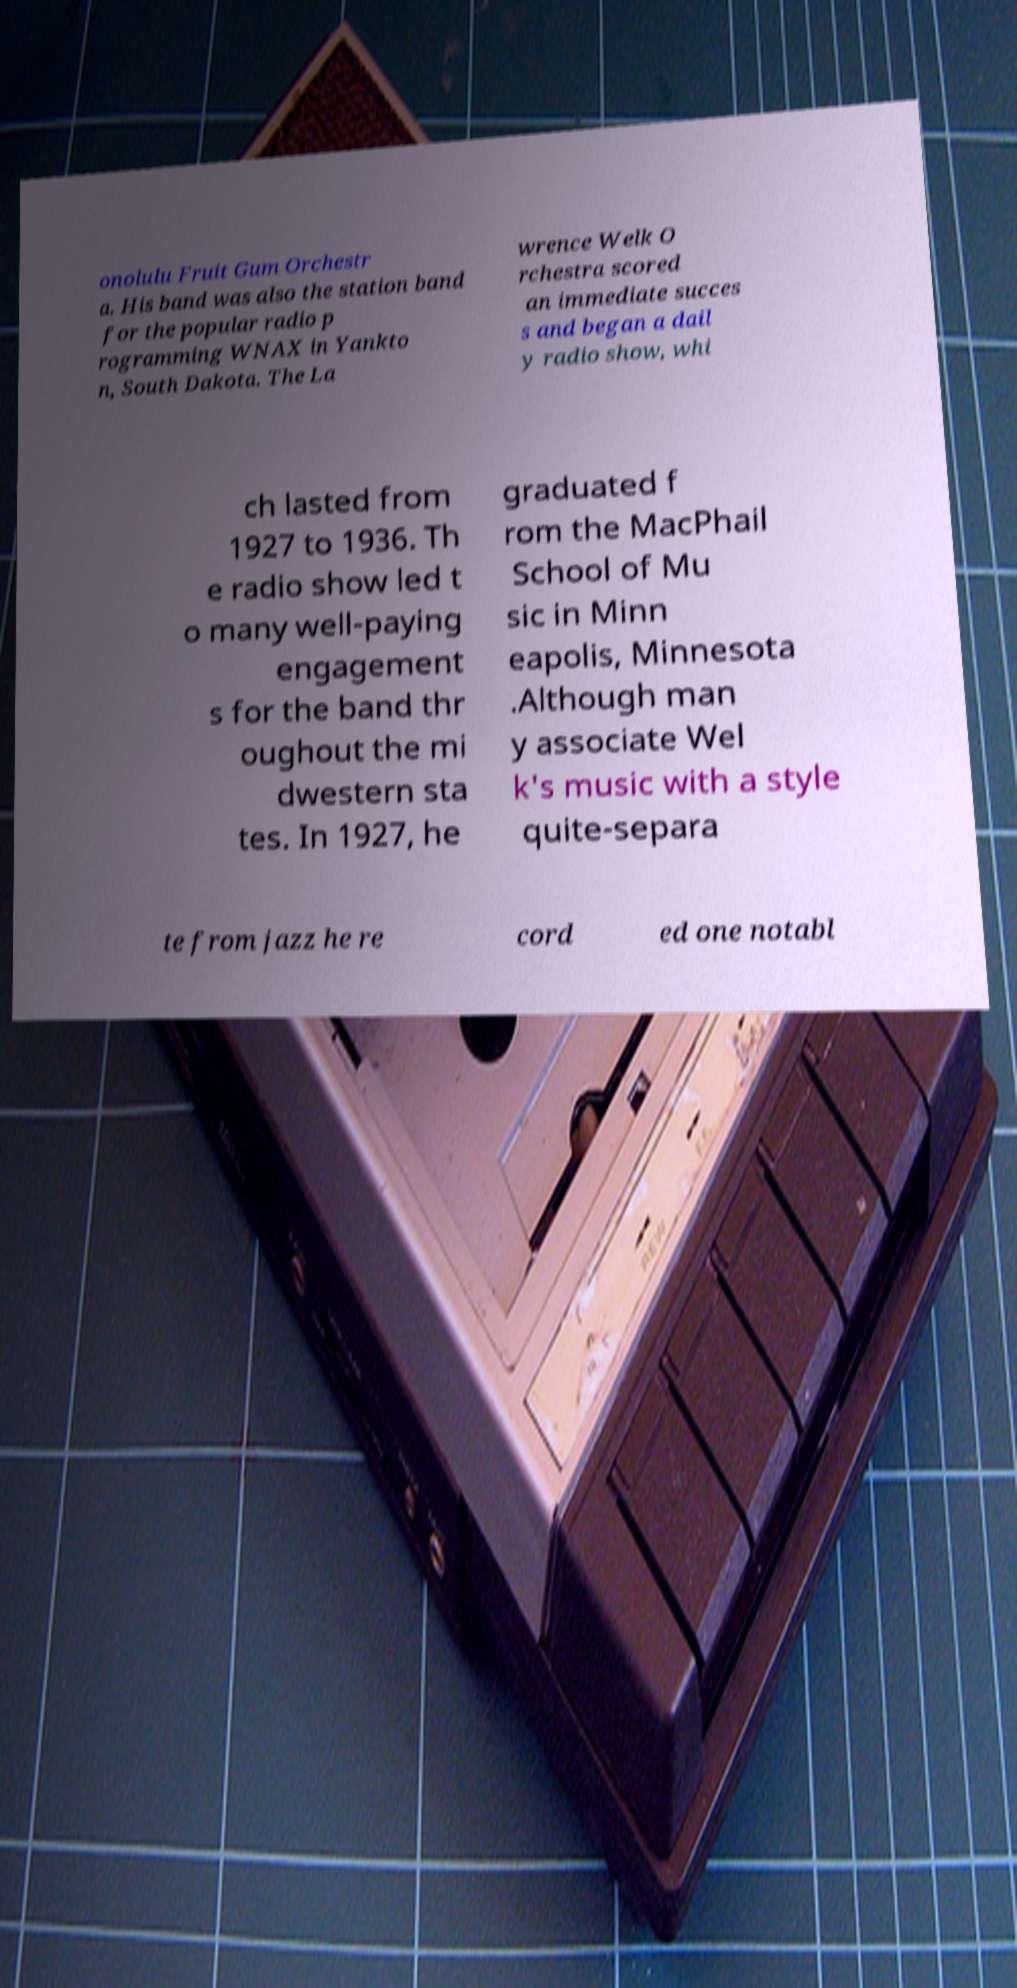There's text embedded in this image that I need extracted. Can you transcribe it verbatim? onolulu Fruit Gum Orchestr a. His band was also the station band for the popular radio p rogramming WNAX in Yankto n, South Dakota. The La wrence Welk O rchestra scored an immediate succes s and began a dail y radio show, whi ch lasted from 1927 to 1936. Th e radio show led t o many well-paying engagement s for the band thr oughout the mi dwestern sta tes. In 1927, he graduated f rom the MacPhail School of Mu sic in Minn eapolis, Minnesota .Although man y associate Wel k's music with a style quite-separa te from jazz he re cord ed one notabl 